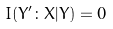Convert formula to latex. <formula><loc_0><loc_0><loc_500><loc_500>I ( Y ^ { \prime } \colon X | Y ) = 0</formula> 